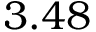Convert formula to latex. <formula><loc_0><loc_0><loc_500><loc_500>3 . 4 8</formula> 